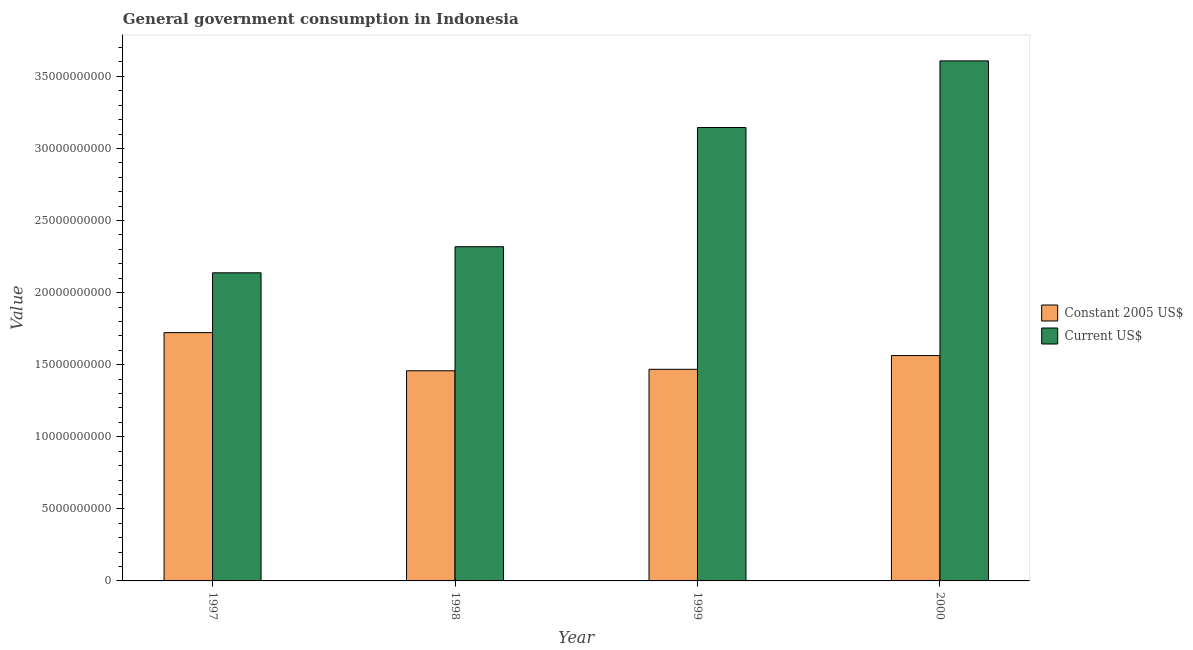How many different coloured bars are there?
Your response must be concise. 2. How many groups of bars are there?
Your response must be concise. 4. Are the number of bars on each tick of the X-axis equal?
Offer a terse response. Yes. How many bars are there on the 4th tick from the left?
Ensure brevity in your answer.  2. How many bars are there on the 1st tick from the right?
Your answer should be compact. 2. What is the label of the 1st group of bars from the left?
Your response must be concise. 1997. In how many cases, is the number of bars for a given year not equal to the number of legend labels?
Provide a short and direct response. 0. What is the value consumed in constant 2005 us$ in 1998?
Your response must be concise. 1.46e+1. Across all years, what is the maximum value consumed in current us$?
Keep it short and to the point. 3.61e+1. Across all years, what is the minimum value consumed in current us$?
Make the answer very short. 2.14e+1. What is the total value consumed in constant 2005 us$ in the graph?
Ensure brevity in your answer.  6.21e+1. What is the difference between the value consumed in current us$ in 1997 and that in 2000?
Keep it short and to the point. -1.47e+1. What is the difference between the value consumed in current us$ in 2000 and the value consumed in constant 2005 us$ in 1997?
Make the answer very short. 1.47e+1. What is the average value consumed in constant 2005 us$ per year?
Your response must be concise. 1.55e+1. In the year 1999, what is the difference between the value consumed in constant 2005 us$ and value consumed in current us$?
Keep it short and to the point. 0. In how many years, is the value consumed in constant 2005 us$ greater than 27000000000?
Provide a short and direct response. 0. What is the ratio of the value consumed in constant 2005 us$ in 1997 to that in 1998?
Give a very brief answer. 1.18. Is the value consumed in constant 2005 us$ in 1999 less than that in 2000?
Offer a terse response. Yes. Is the difference between the value consumed in constant 2005 us$ in 1997 and 1998 greater than the difference between the value consumed in current us$ in 1997 and 1998?
Provide a short and direct response. No. What is the difference between the highest and the second highest value consumed in current us$?
Keep it short and to the point. 4.62e+09. What is the difference between the highest and the lowest value consumed in current us$?
Ensure brevity in your answer.  1.47e+1. In how many years, is the value consumed in current us$ greater than the average value consumed in current us$ taken over all years?
Make the answer very short. 2. Is the sum of the value consumed in current us$ in 1998 and 1999 greater than the maximum value consumed in constant 2005 us$ across all years?
Ensure brevity in your answer.  Yes. What does the 1st bar from the left in 1997 represents?
Your response must be concise. Constant 2005 US$. What does the 2nd bar from the right in 2000 represents?
Provide a short and direct response. Constant 2005 US$. How many bars are there?
Your answer should be very brief. 8. Are all the bars in the graph horizontal?
Provide a succinct answer. No. Does the graph contain any zero values?
Offer a terse response. No. Does the graph contain grids?
Your response must be concise. No. Where does the legend appear in the graph?
Make the answer very short. Center right. How many legend labels are there?
Provide a short and direct response. 2. What is the title of the graph?
Give a very brief answer. General government consumption in Indonesia. What is the label or title of the X-axis?
Your answer should be compact. Year. What is the label or title of the Y-axis?
Make the answer very short. Value. What is the Value of Constant 2005 US$ in 1997?
Provide a succinct answer. 1.72e+1. What is the Value of Current US$ in 1997?
Offer a very short reply. 2.14e+1. What is the Value in Constant 2005 US$ in 1998?
Offer a terse response. 1.46e+1. What is the Value of Current US$ in 1998?
Give a very brief answer. 2.32e+1. What is the Value in Constant 2005 US$ in 1999?
Offer a terse response. 1.47e+1. What is the Value of Current US$ in 1999?
Your answer should be compact. 3.15e+1. What is the Value in Constant 2005 US$ in 2000?
Offer a terse response. 1.56e+1. What is the Value in Current US$ in 2000?
Make the answer very short. 3.61e+1. Across all years, what is the maximum Value in Constant 2005 US$?
Ensure brevity in your answer.  1.72e+1. Across all years, what is the maximum Value of Current US$?
Your answer should be very brief. 3.61e+1. Across all years, what is the minimum Value of Constant 2005 US$?
Give a very brief answer. 1.46e+1. Across all years, what is the minimum Value in Current US$?
Provide a succinct answer. 2.14e+1. What is the total Value of Constant 2005 US$ in the graph?
Offer a terse response. 6.21e+1. What is the total Value in Current US$ in the graph?
Ensure brevity in your answer.  1.12e+11. What is the difference between the Value in Constant 2005 US$ in 1997 and that in 1998?
Provide a succinct answer. 2.65e+09. What is the difference between the Value of Current US$ in 1997 and that in 1998?
Keep it short and to the point. -1.81e+09. What is the difference between the Value in Constant 2005 US$ in 1997 and that in 1999?
Offer a terse response. 2.55e+09. What is the difference between the Value in Current US$ in 1997 and that in 1999?
Your response must be concise. -1.01e+1. What is the difference between the Value in Constant 2005 US$ in 1997 and that in 2000?
Your response must be concise. 1.59e+09. What is the difference between the Value of Current US$ in 1997 and that in 2000?
Ensure brevity in your answer.  -1.47e+1. What is the difference between the Value in Constant 2005 US$ in 1998 and that in 1999?
Provide a short and direct response. -1.01e+08. What is the difference between the Value of Current US$ in 1998 and that in 1999?
Your answer should be compact. -8.27e+09. What is the difference between the Value in Constant 2005 US$ in 1998 and that in 2000?
Offer a terse response. -1.05e+09. What is the difference between the Value of Current US$ in 1998 and that in 2000?
Your answer should be compact. -1.29e+1. What is the difference between the Value of Constant 2005 US$ in 1999 and that in 2000?
Your answer should be very brief. -9.53e+08. What is the difference between the Value in Current US$ in 1999 and that in 2000?
Give a very brief answer. -4.62e+09. What is the difference between the Value of Constant 2005 US$ in 1997 and the Value of Current US$ in 1998?
Provide a short and direct response. -5.96e+09. What is the difference between the Value in Constant 2005 US$ in 1997 and the Value in Current US$ in 1999?
Offer a terse response. -1.42e+1. What is the difference between the Value in Constant 2005 US$ in 1997 and the Value in Current US$ in 2000?
Your response must be concise. -1.88e+1. What is the difference between the Value of Constant 2005 US$ in 1998 and the Value of Current US$ in 1999?
Ensure brevity in your answer.  -1.69e+1. What is the difference between the Value of Constant 2005 US$ in 1998 and the Value of Current US$ in 2000?
Offer a terse response. -2.15e+1. What is the difference between the Value of Constant 2005 US$ in 1999 and the Value of Current US$ in 2000?
Offer a very short reply. -2.14e+1. What is the average Value of Constant 2005 US$ per year?
Your answer should be very brief. 1.55e+1. What is the average Value in Current US$ per year?
Your response must be concise. 2.80e+1. In the year 1997, what is the difference between the Value of Constant 2005 US$ and Value of Current US$?
Ensure brevity in your answer.  -4.15e+09. In the year 1998, what is the difference between the Value of Constant 2005 US$ and Value of Current US$?
Your response must be concise. -8.60e+09. In the year 1999, what is the difference between the Value in Constant 2005 US$ and Value in Current US$?
Make the answer very short. -1.68e+1. In the year 2000, what is the difference between the Value of Constant 2005 US$ and Value of Current US$?
Provide a succinct answer. -2.04e+1. What is the ratio of the Value of Constant 2005 US$ in 1997 to that in 1998?
Make the answer very short. 1.18. What is the ratio of the Value of Current US$ in 1997 to that in 1998?
Keep it short and to the point. 0.92. What is the ratio of the Value in Constant 2005 US$ in 1997 to that in 1999?
Offer a terse response. 1.17. What is the ratio of the Value in Current US$ in 1997 to that in 1999?
Your answer should be very brief. 0.68. What is the ratio of the Value in Constant 2005 US$ in 1997 to that in 2000?
Your answer should be very brief. 1.1. What is the ratio of the Value in Current US$ in 1997 to that in 2000?
Your response must be concise. 0.59. What is the ratio of the Value in Current US$ in 1998 to that in 1999?
Provide a succinct answer. 0.74. What is the ratio of the Value in Constant 2005 US$ in 1998 to that in 2000?
Give a very brief answer. 0.93. What is the ratio of the Value of Current US$ in 1998 to that in 2000?
Make the answer very short. 0.64. What is the ratio of the Value in Constant 2005 US$ in 1999 to that in 2000?
Offer a terse response. 0.94. What is the ratio of the Value in Current US$ in 1999 to that in 2000?
Keep it short and to the point. 0.87. What is the difference between the highest and the second highest Value in Constant 2005 US$?
Make the answer very short. 1.59e+09. What is the difference between the highest and the second highest Value of Current US$?
Offer a terse response. 4.62e+09. What is the difference between the highest and the lowest Value in Constant 2005 US$?
Ensure brevity in your answer.  2.65e+09. What is the difference between the highest and the lowest Value of Current US$?
Give a very brief answer. 1.47e+1. 